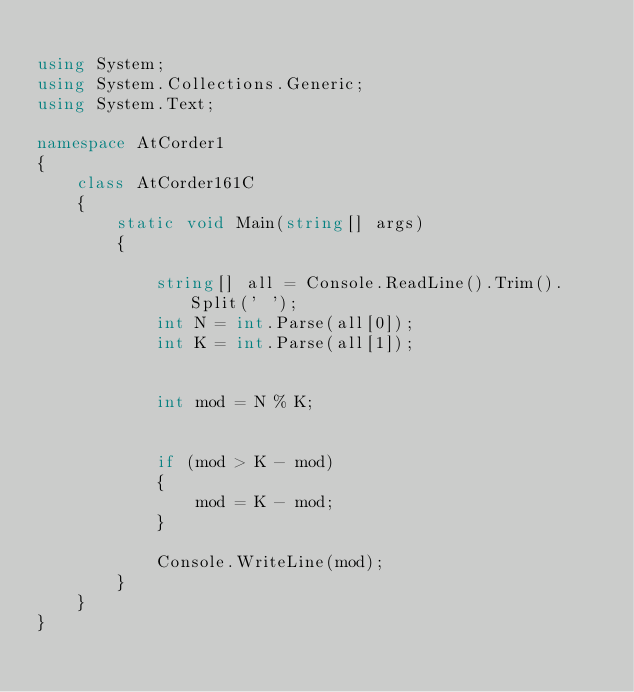<code> <loc_0><loc_0><loc_500><loc_500><_C#_>
using System;
using System.Collections.Generic;
using System.Text;

namespace AtCorder1
{
    class AtCorder161C
    {
        static void Main(string[] args)
        {

            string[] all = Console.ReadLine().Trim().Split(' ');
            int N = int.Parse(all[0]);
            int K = int.Parse(all[1]);


            int mod = N % K;


            if (mod > K - mod)
            {
                mod = K - mod;
            }

            Console.WriteLine(mod);
        }
    }
}
</code> 